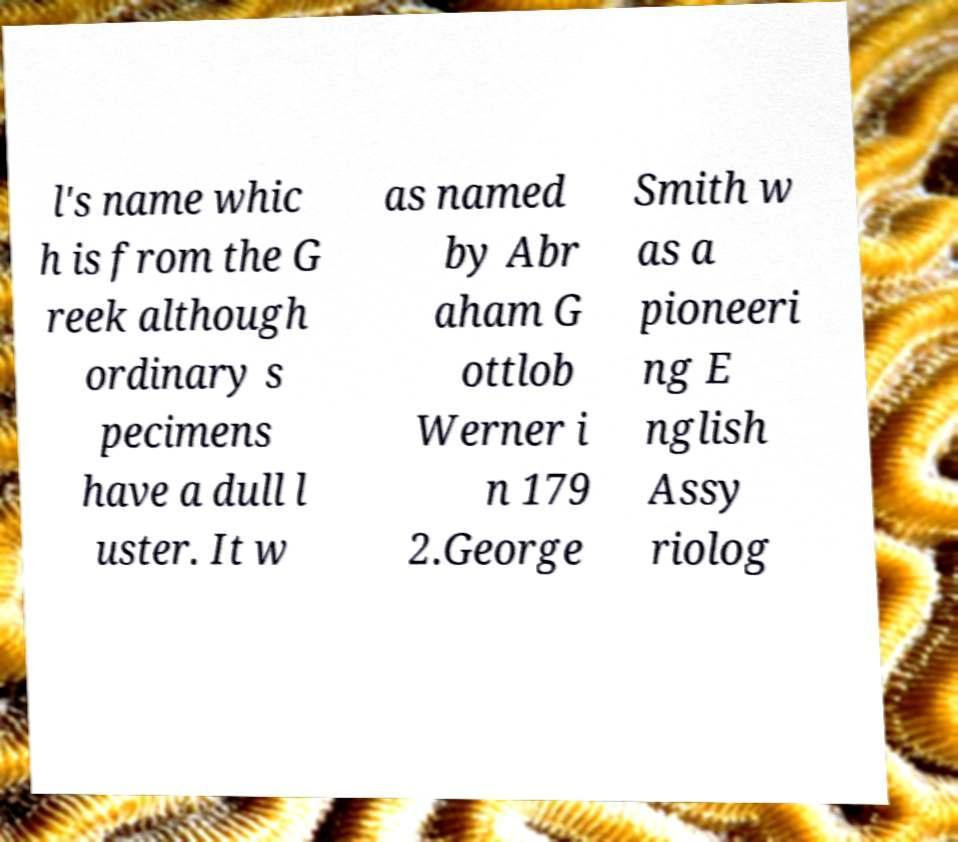I need the written content from this picture converted into text. Can you do that? l's name whic h is from the G reek although ordinary s pecimens have a dull l uster. It w as named by Abr aham G ottlob Werner i n 179 2.George Smith w as a pioneeri ng E nglish Assy riolog 